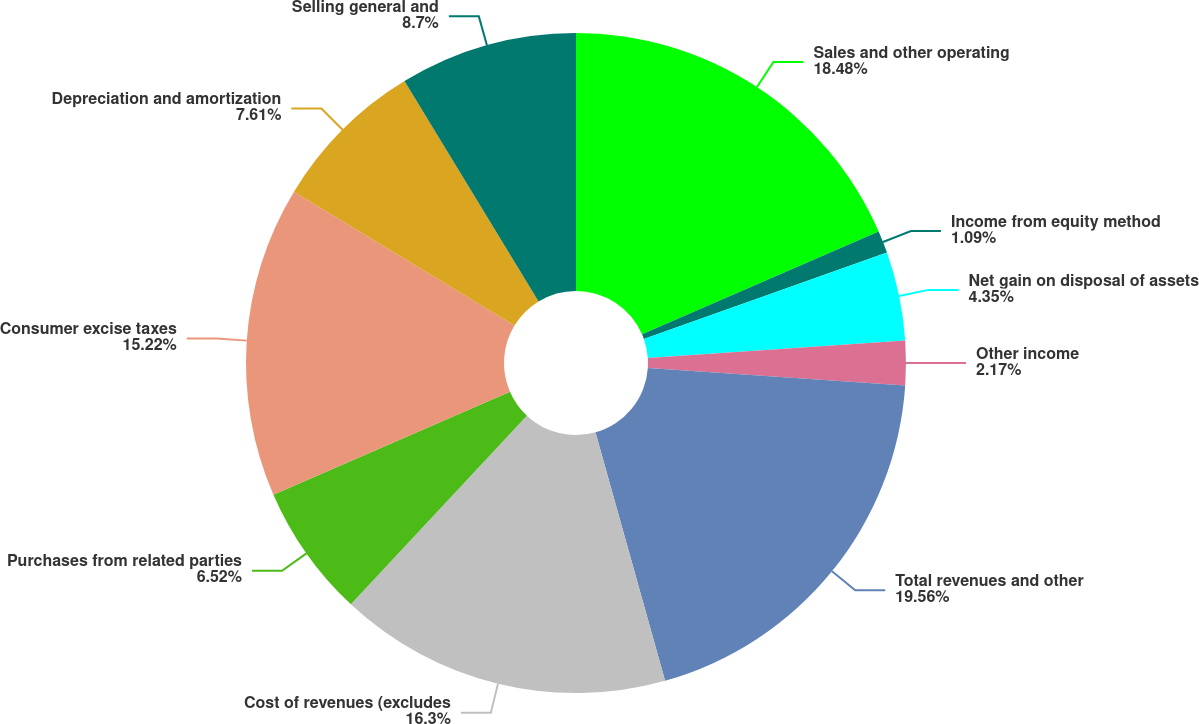<chart> <loc_0><loc_0><loc_500><loc_500><pie_chart><fcel>Sales and other operating<fcel>Income from equity method<fcel>Net gain on disposal of assets<fcel>Other income<fcel>Total revenues and other<fcel>Cost of revenues (excludes<fcel>Purchases from related parties<fcel>Consumer excise taxes<fcel>Depreciation and amortization<fcel>Selling general and<nl><fcel>18.48%<fcel>1.09%<fcel>4.35%<fcel>2.17%<fcel>19.56%<fcel>16.3%<fcel>6.52%<fcel>15.22%<fcel>7.61%<fcel>8.7%<nl></chart> 